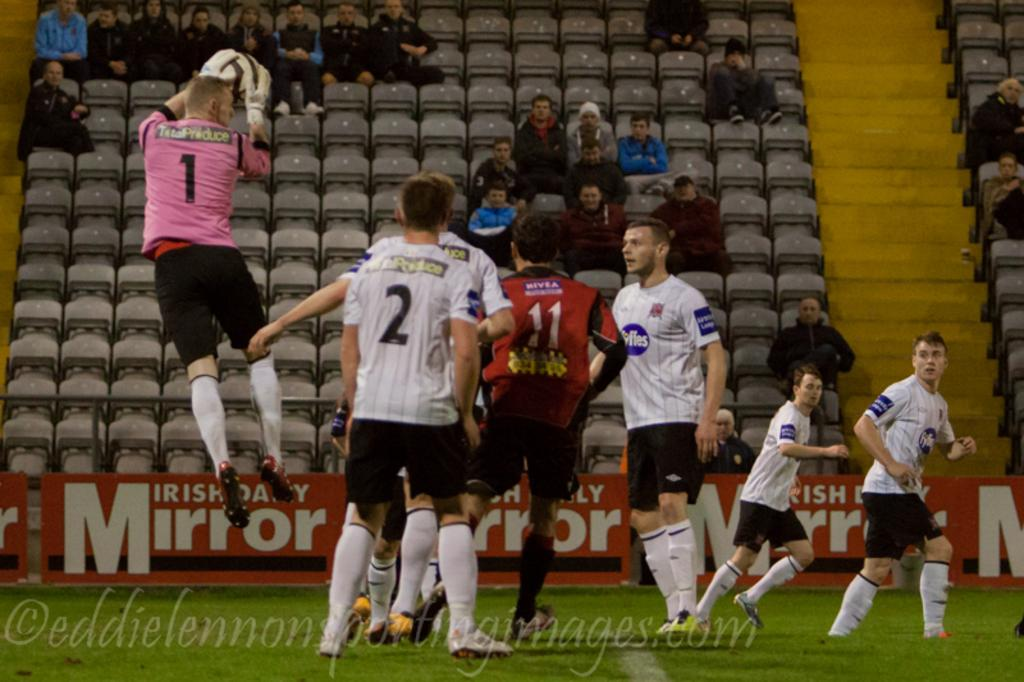<image>
Render a clear and concise summary of the photo. The soccer team is sponsored by the Irish Daily Mirror. 